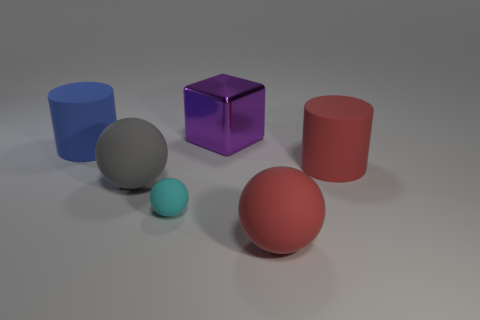Add 3 tiny green matte spheres. How many objects exist? 9 Subtract all cylinders. How many objects are left? 4 Subtract 1 blue cylinders. How many objects are left? 5 Subtract all cyan spheres. Subtract all big things. How many objects are left? 0 Add 2 large rubber spheres. How many large rubber spheres are left? 4 Add 4 big gray things. How many big gray things exist? 5 